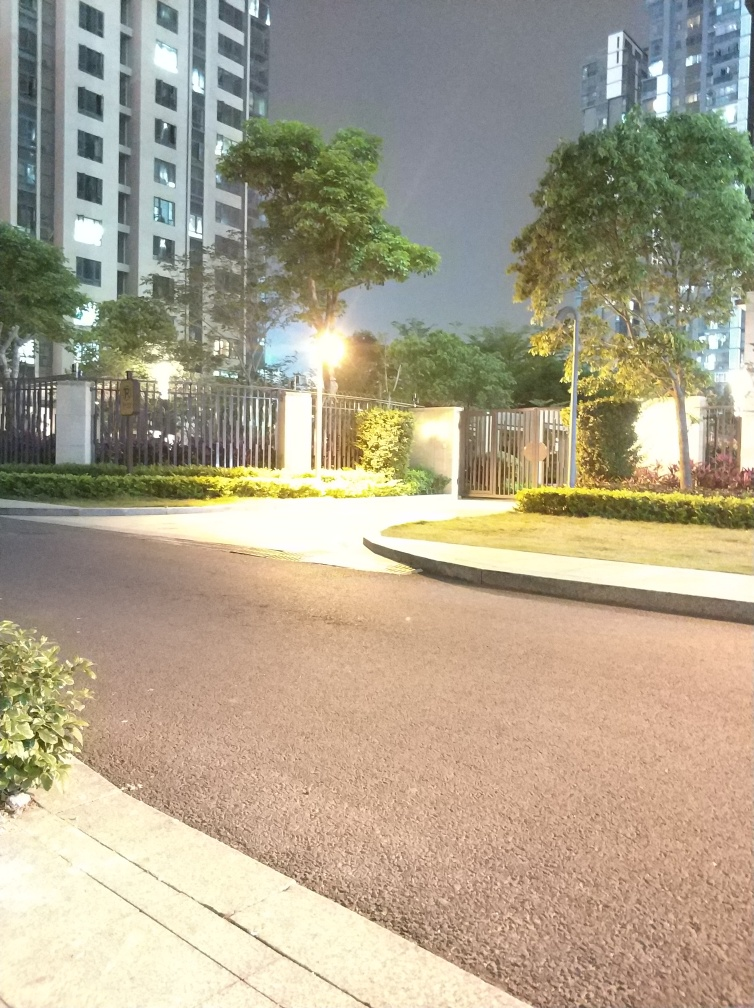Can you describe the setting captured in this image? This image depicts an urban nighttime scene, likely within a residential area. It features a well-lit street with a sidewalk, green hedges, and a tall, multi-story residential building in the background. The street lamp provides bright illumination that contrasts with the darkness of the night sky. What time of day does this image suggest? The image suggests that it was taken at night, as indicated by the dark sky and the artificial lights from the street lamp and within the residential building. 